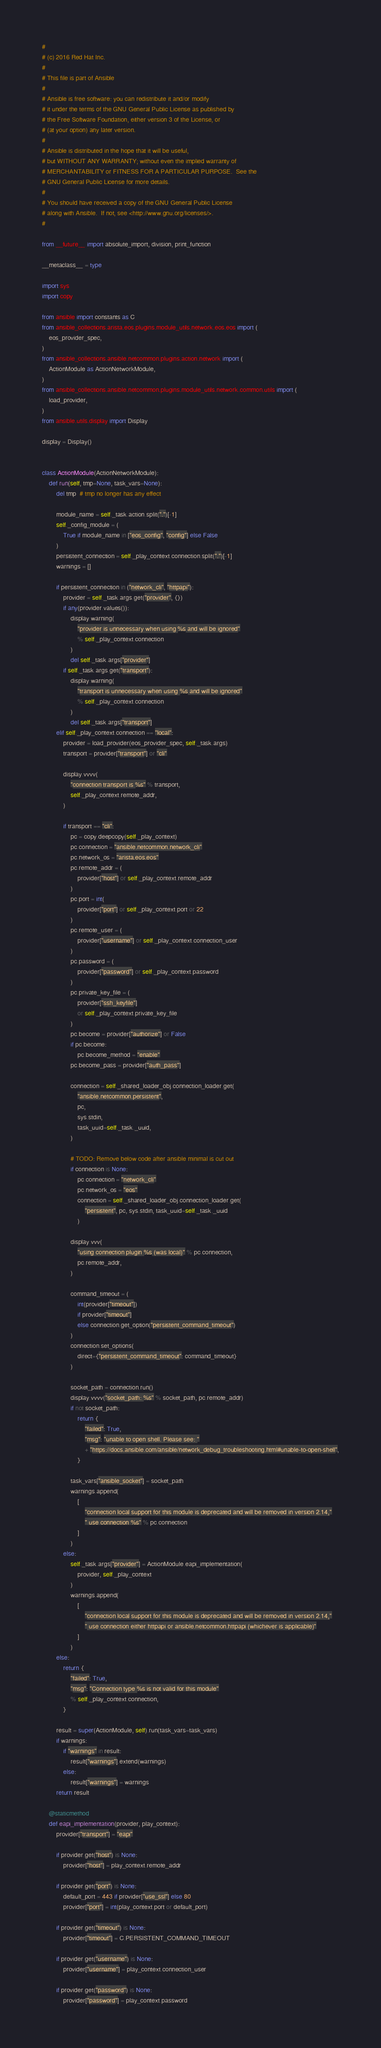Convert code to text. <code><loc_0><loc_0><loc_500><loc_500><_Python_>#
# (c) 2016 Red Hat Inc.
#
# This file is part of Ansible
#
# Ansible is free software: you can redistribute it and/or modify
# it under the terms of the GNU General Public License as published by
# the Free Software Foundation, either version 3 of the License, or
# (at your option) any later version.
#
# Ansible is distributed in the hope that it will be useful,
# but WITHOUT ANY WARRANTY; without even the implied warranty of
# MERCHANTABILITY or FITNESS FOR A PARTICULAR PURPOSE.  See the
# GNU General Public License for more details.
#
# You should have received a copy of the GNU General Public License
# along with Ansible.  If not, see <http://www.gnu.org/licenses/>.
#

from __future__ import absolute_import, division, print_function

__metaclass__ = type

import sys
import copy

from ansible import constants as C
from ansible_collections.arista.eos.plugins.module_utils.network.eos.eos import (
    eos_provider_spec,
)
from ansible_collections.ansible.netcommon.plugins.action.network import (
    ActionModule as ActionNetworkModule,
)
from ansible_collections.ansible.netcommon.plugins.module_utils.network.common.utils import (
    load_provider,
)
from ansible.utils.display import Display

display = Display()


class ActionModule(ActionNetworkModule):
    def run(self, tmp=None, task_vars=None):
        del tmp  # tmp no longer has any effect

        module_name = self._task.action.split(".")[-1]
        self._config_module = (
            True if module_name in ["eos_config", "config"] else False
        )
        persistent_connection = self._play_context.connection.split(".")[-1]
        warnings = []

        if persistent_connection in ("network_cli", "httpapi"):
            provider = self._task.args.get("provider", {})
            if any(provider.values()):
                display.warning(
                    "provider is unnecessary when using %s and will be ignored"
                    % self._play_context.connection
                )
                del self._task.args["provider"]
            if self._task.args.get("transport"):
                display.warning(
                    "transport is unnecessary when using %s and will be ignored"
                    % self._play_context.connection
                )
                del self._task.args["transport"]
        elif self._play_context.connection == "local":
            provider = load_provider(eos_provider_spec, self._task.args)
            transport = provider["transport"] or "cli"

            display.vvvv(
                "connection transport is %s" % transport,
                self._play_context.remote_addr,
            )

            if transport == "cli":
                pc = copy.deepcopy(self._play_context)
                pc.connection = "ansible.netcommon.network_cli"
                pc.network_os = "arista.eos.eos"
                pc.remote_addr = (
                    provider["host"] or self._play_context.remote_addr
                )
                pc.port = int(
                    provider["port"] or self._play_context.port or 22
                )
                pc.remote_user = (
                    provider["username"] or self._play_context.connection_user
                )
                pc.password = (
                    provider["password"] or self._play_context.password
                )
                pc.private_key_file = (
                    provider["ssh_keyfile"]
                    or self._play_context.private_key_file
                )
                pc.become = provider["authorize"] or False
                if pc.become:
                    pc.become_method = "enable"
                pc.become_pass = provider["auth_pass"]

                connection = self._shared_loader_obj.connection_loader.get(
                    "ansible.netcommon.persistent",
                    pc,
                    sys.stdin,
                    task_uuid=self._task._uuid,
                )

                # TODO: Remove below code after ansible minimal is cut out
                if connection is None:
                    pc.connection = "network_cli"
                    pc.network_os = "eos"
                    connection = self._shared_loader_obj.connection_loader.get(
                        "persistent", pc, sys.stdin, task_uuid=self._task._uuid
                    )

                display.vvv(
                    "using connection plugin %s (was local)" % pc.connection,
                    pc.remote_addr,
                )

                command_timeout = (
                    int(provider["timeout"])
                    if provider["timeout"]
                    else connection.get_option("persistent_command_timeout")
                )
                connection.set_options(
                    direct={"persistent_command_timeout": command_timeout}
                )

                socket_path = connection.run()
                display.vvvv("socket_path: %s" % socket_path, pc.remote_addr)
                if not socket_path:
                    return {
                        "failed": True,
                        "msg": "unable to open shell. Please see: "
                        + "https://docs.ansible.com/ansible/network_debug_troubleshooting.html#unable-to-open-shell",
                    }

                task_vars["ansible_socket"] = socket_path
                warnings.append(
                    [
                        "connection local support for this module is deprecated and will be removed in version 2.14,"
                        " use connection %s" % pc.connection
                    ]
                )
            else:
                self._task.args["provider"] = ActionModule.eapi_implementation(
                    provider, self._play_context
                )
                warnings.append(
                    [
                        "connection local support for this module is deprecated and will be removed in version 2.14,"
                        " use connection either httpapi or ansible.netcommon.httpapi (whichever is applicable)"
                    ]
                )
        else:
            return {
                "failed": True,
                "msg": "Connection type %s is not valid for this module"
                % self._play_context.connection,
            }

        result = super(ActionModule, self).run(task_vars=task_vars)
        if warnings:
            if "warnings" in result:
                result["warnings"].extend(warnings)
            else:
                result["warnings"] = warnings
        return result

    @staticmethod
    def eapi_implementation(provider, play_context):
        provider["transport"] = "eapi"

        if provider.get("host") is None:
            provider["host"] = play_context.remote_addr

        if provider.get("port") is None:
            default_port = 443 if provider["use_ssl"] else 80
            provider["port"] = int(play_context.port or default_port)

        if provider.get("timeout") is None:
            provider["timeout"] = C.PERSISTENT_COMMAND_TIMEOUT

        if provider.get("username") is None:
            provider["username"] = play_context.connection_user

        if provider.get("password") is None:
            provider["password"] = play_context.password
</code> 